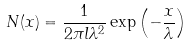<formula> <loc_0><loc_0><loc_500><loc_500>N ( x ) = \frac { 1 } { 2 \pi l \lambda ^ { 2 } } \exp \left ( - \frac { x } { \lambda } \right )</formula> 